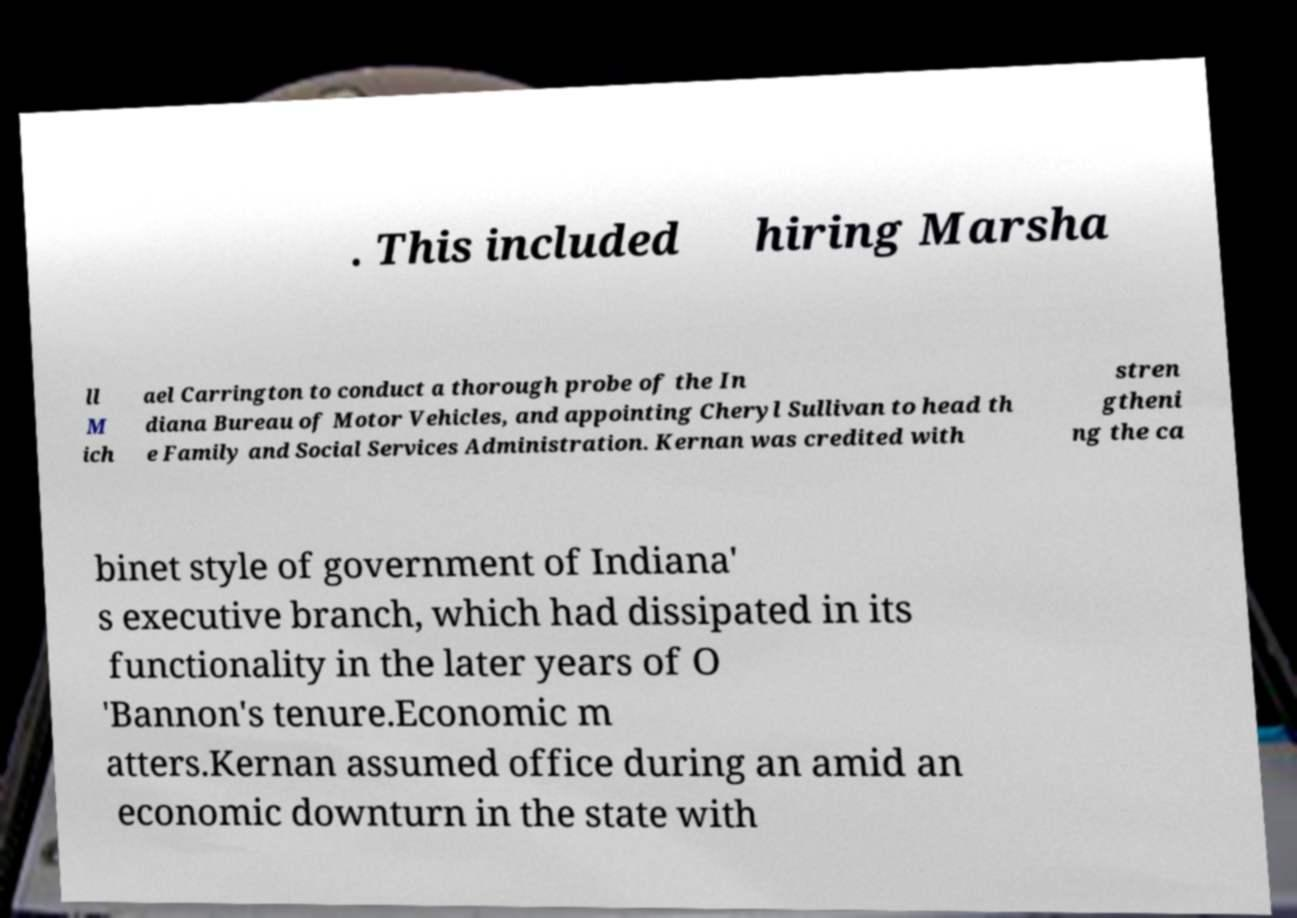Please identify and transcribe the text found in this image. . This included hiring Marsha ll M ich ael Carrington to conduct a thorough probe of the In diana Bureau of Motor Vehicles, and appointing Cheryl Sullivan to head th e Family and Social Services Administration. Kernan was credited with stren gtheni ng the ca binet style of government of Indiana' s executive branch, which had dissipated in its functionality in the later years of O 'Bannon's tenure.Economic m atters.Kernan assumed office during an amid an economic downturn in the state with 